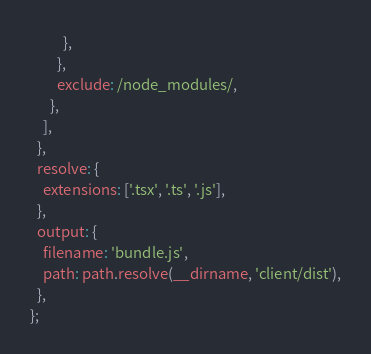<code> <loc_0><loc_0><loc_500><loc_500><_JavaScript_>          },
        },
        exclude: /node_modules/,
      },
    ],
  },
  resolve: {
    extensions: ['.tsx', '.ts', '.js'],
  },
  output: {
    filename: 'bundle.js',
    path: path.resolve(__dirname, 'client/dist'),
  },
};
</code> 